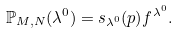<formula> <loc_0><loc_0><loc_500><loc_500>\mathbb { P } _ { M , N } ( \lambda ^ { 0 } ) = s _ { \lambda ^ { 0 } } ( p ) f ^ { \lambda ^ { 0 } } .</formula> 